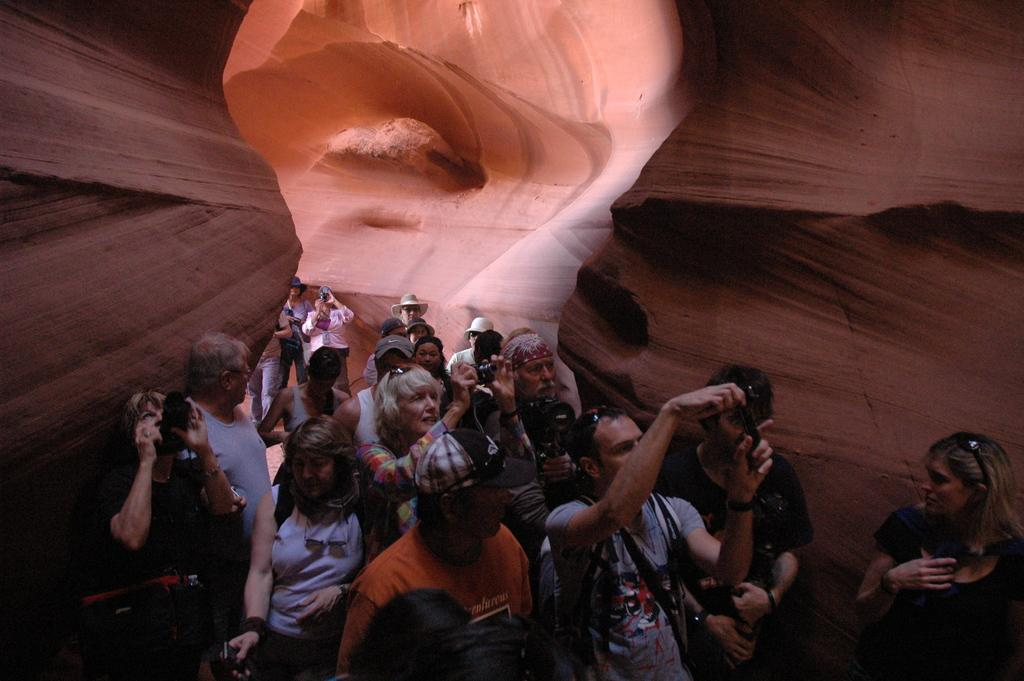Where are the people located in the image? The people are inside the cave. What are some people wearing on their heads? Some people are wearing hats or caps. What are some people carrying in the image? Some people are wearing bags. Can you see a sofa in the image? There is no sofa present in the image; it takes place inside a cave. 